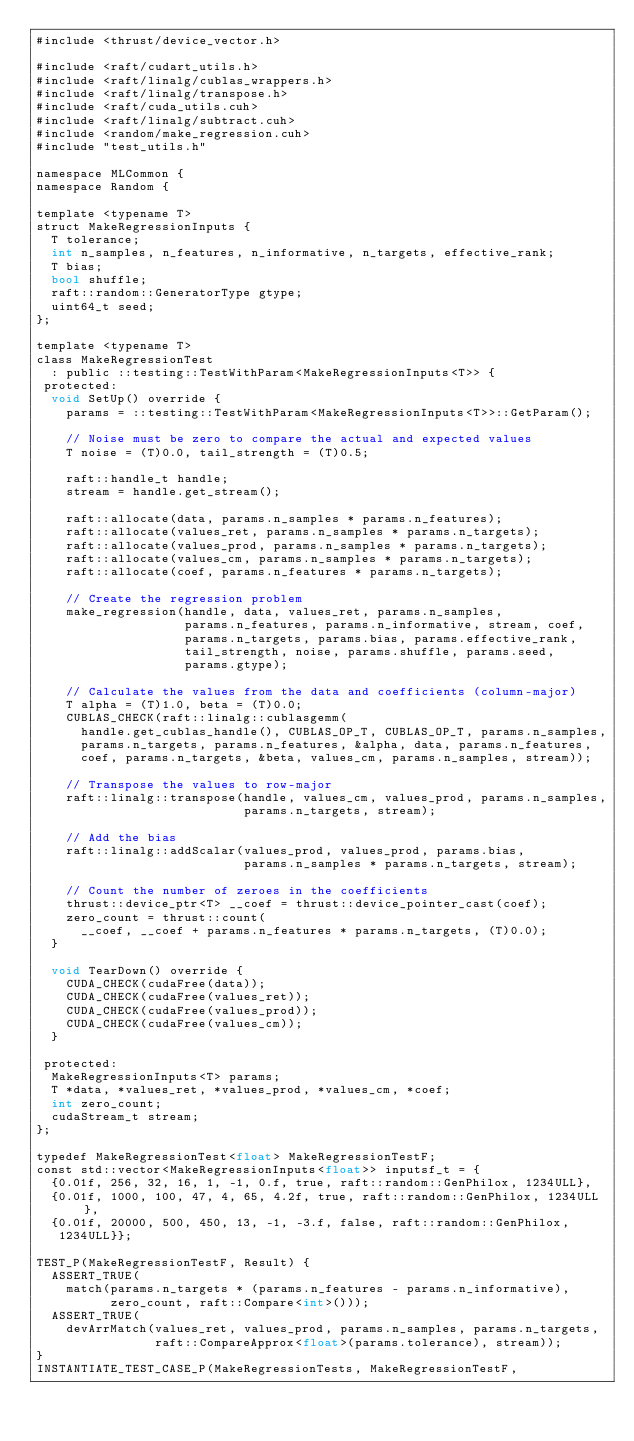<code> <loc_0><loc_0><loc_500><loc_500><_Cuda_>#include <thrust/device_vector.h>

#include <raft/cudart_utils.h>
#include <raft/linalg/cublas_wrappers.h>
#include <raft/linalg/transpose.h>
#include <raft/cuda_utils.cuh>
#include <raft/linalg/subtract.cuh>
#include <random/make_regression.cuh>
#include "test_utils.h"

namespace MLCommon {
namespace Random {

template <typename T>
struct MakeRegressionInputs {
  T tolerance;
  int n_samples, n_features, n_informative, n_targets, effective_rank;
  T bias;
  bool shuffle;
  raft::random::GeneratorType gtype;
  uint64_t seed;
};

template <typename T>
class MakeRegressionTest
  : public ::testing::TestWithParam<MakeRegressionInputs<T>> {
 protected:
  void SetUp() override {
    params = ::testing::TestWithParam<MakeRegressionInputs<T>>::GetParam();

    // Noise must be zero to compare the actual and expected values
    T noise = (T)0.0, tail_strength = (T)0.5;

    raft::handle_t handle;
    stream = handle.get_stream();

    raft::allocate(data, params.n_samples * params.n_features);
    raft::allocate(values_ret, params.n_samples * params.n_targets);
    raft::allocate(values_prod, params.n_samples * params.n_targets);
    raft::allocate(values_cm, params.n_samples * params.n_targets);
    raft::allocate(coef, params.n_features * params.n_targets);

    // Create the regression problem
    make_regression(handle, data, values_ret, params.n_samples,
                    params.n_features, params.n_informative, stream, coef,
                    params.n_targets, params.bias, params.effective_rank,
                    tail_strength, noise, params.shuffle, params.seed,
                    params.gtype);

    // Calculate the values from the data and coefficients (column-major)
    T alpha = (T)1.0, beta = (T)0.0;
    CUBLAS_CHECK(raft::linalg::cublasgemm(
      handle.get_cublas_handle(), CUBLAS_OP_T, CUBLAS_OP_T, params.n_samples,
      params.n_targets, params.n_features, &alpha, data, params.n_features,
      coef, params.n_targets, &beta, values_cm, params.n_samples, stream));

    // Transpose the values to row-major
    raft::linalg::transpose(handle, values_cm, values_prod, params.n_samples,
                            params.n_targets, stream);

    // Add the bias
    raft::linalg::addScalar(values_prod, values_prod, params.bias,
                            params.n_samples * params.n_targets, stream);

    // Count the number of zeroes in the coefficients
    thrust::device_ptr<T> __coef = thrust::device_pointer_cast(coef);
    zero_count = thrust::count(
      __coef, __coef + params.n_features * params.n_targets, (T)0.0);
  }

  void TearDown() override {
    CUDA_CHECK(cudaFree(data));
    CUDA_CHECK(cudaFree(values_ret));
    CUDA_CHECK(cudaFree(values_prod));
    CUDA_CHECK(cudaFree(values_cm));
  }

 protected:
  MakeRegressionInputs<T> params;
  T *data, *values_ret, *values_prod, *values_cm, *coef;
  int zero_count;
  cudaStream_t stream;
};

typedef MakeRegressionTest<float> MakeRegressionTestF;
const std::vector<MakeRegressionInputs<float>> inputsf_t = {
  {0.01f, 256, 32, 16, 1, -1, 0.f, true, raft::random::GenPhilox, 1234ULL},
  {0.01f, 1000, 100, 47, 4, 65, 4.2f, true, raft::random::GenPhilox, 1234ULL},
  {0.01f, 20000, 500, 450, 13, -1, -3.f, false, raft::random::GenPhilox,
   1234ULL}};

TEST_P(MakeRegressionTestF, Result) {
  ASSERT_TRUE(
    match(params.n_targets * (params.n_features - params.n_informative),
          zero_count, raft::Compare<int>()));
  ASSERT_TRUE(
    devArrMatch(values_ret, values_prod, params.n_samples, params.n_targets,
                raft::CompareApprox<float>(params.tolerance), stream));
}
INSTANTIATE_TEST_CASE_P(MakeRegressionTests, MakeRegressionTestF,</code> 